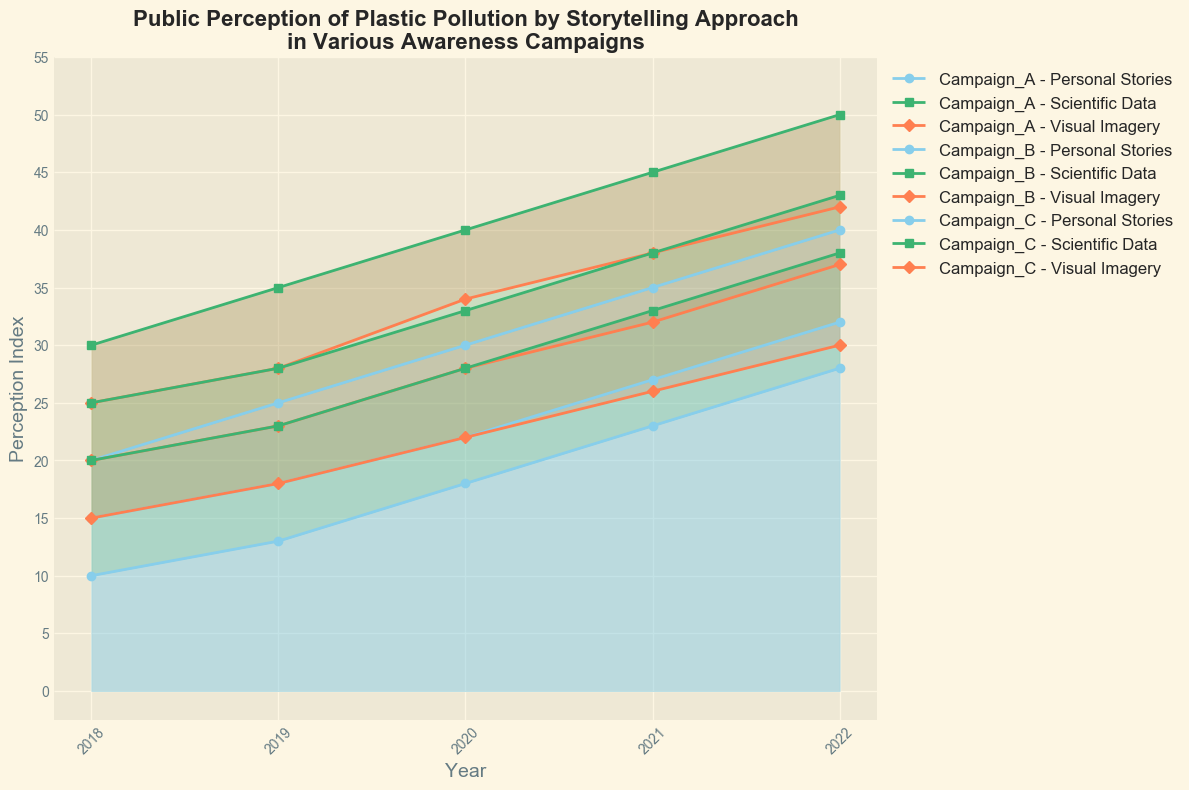What's the overall trend in public perception for Campaign A from 2018 to 2022? To determine the overall trend, look at the curves for Personal Stories, Scientific Data, and Visual Imagery for Campaign A from 2018 to 2022. Each curve shows an increase over the years.
Answer: Increasing Which campaign shows the highest perception index for Visual Imagery in 2022? Compare the perception indexes for Visual Imagery in 2022 across all campaigns. Campaign A has the highest value at 42.
Answer: Campaign A How does the growth of public perception in Personal Stories compare between Campaign A and Campaign C from 2018 to 2022? For Campaign A, Personal Stories increase from 20 in 2018 to 40 in 2022, a growth of 20. For Campaign C, Personal Stories increase from 10 in 2018 to 28 in 2022, a growth of 18.
Answer: Campaign A has a greater growth What's the difference in public perception for Scientific Data between Campaign B and Campaign C in 2020? In 2020, Scientific Data perception for Campaign B is 33, and for Campaign C it is 28. The difference is 33 - 28.
Answer: 5 Which method of storytelling consistently leads to the highest public perception across all campaigns? Observe the heights of the different segments (Personal Stories, Scientific Data, Visual Imagery) for all campaigns across the years. Scientific Data mostly appears as the highest segment.
Answer: Scientific Data Compare the increase in the perception index for Personal Stories between 2018 and 2022 for Campaign A and Campaign B. For Campaign A, Personal Stories increase from 20 in 2018 to 40 in 2022, an increase of 20. For Campaign B, they increase from 15 in 2018 to 32 in 2022, an increase of 17.
Answer: Campaign A shows a greater increase What is the visual trend of perception index for Scientific Data for all campaigns from 2018 to 2022? Each campaign's Scientific Data line (middle section colored in green) shows an increasing trend from 2018 to 2022.
Answer: Increasing What's the combined perception index for Personal Stories and Scientific Data for Campaign A in 2021? For 2021, the perception index for Personal Stories is 35 and for Scientific Data is 45. Adding these values: 35 + 45.
Answer: 80 What can be inferred about the perception of Visual Imagery between Campaign A and Campaign C over the years? The perception index for Visual Imagery in Campaign A is consistently higher compared to Campaign C, increasing steadily for both campaigns from 2018 to 2022.
Answer: Campaign A is higher Is the public perception more influenced by Personal Stories or Visual Imagery in Campaign B in 2020? For Campaign B in 2020, the index for Personal Stories is 22 while for Visual Imagery it is 28.
Answer: Visual Imagery 